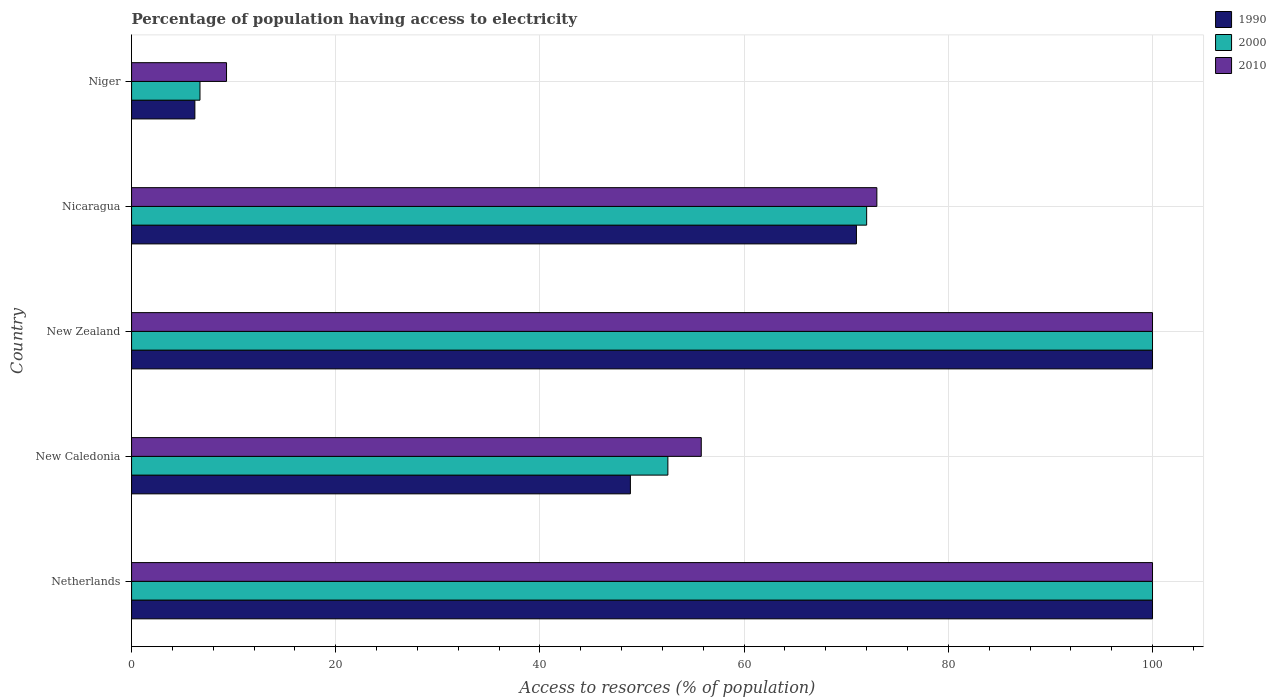How many groups of bars are there?
Offer a terse response. 5. Are the number of bars per tick equal to the number of legend labels?
Ensure brevity in your answer.  Yes. Are the number of bars on each tick of the Y-axis equal?
Your answer should be compact. Yes. How many bars are there on the 1st tick from the top?
Your answer should be very brief. 3. How many bars are there on the 4th tick from the bottom?
Provide a succinct answer. 3. What is the label of the 3rd group of bars from the top?
Provide a short and direct response. New Zealand. Across all countries, what is the minimum percentage of population having access to electricity in 2010?
Keep it short and to the point. 9.3. In which country was the percentage of population having access to electricity in 2000 minimum?
Your answer should be very brief. Niger. What is the total percentage of population having access to electricity in 2000 in the graph?
Offer a very short reply. 331.23. What is the difference between the percentage of population having access to electricity in 2010 in New Caledonia and that in New Zealand?
Make the answer very short. -44.2. What is the average percentage of population having access to electricity in 1990 per country?
Make the answer very short. 65.21. What is the difference between the percentage of population having access to electricity in 2010 and percentage of population having access to electricity in 1990 in Netherlands?
Offer a very short reply. 0. In how many countries, is the percentage of population having access to electricity in 2010 greater than 8 %?
Your answer should be compact. 5. What is the ratio of the percentage of population having access to electricity in 2000 in New Caledonia to that in Niger?
Offer a very short reply. 7.84. Is the difference between the percentage of population having access to electricity in 2010 in Netherlands and Niger greater than the difference between the percentage of population having access to electricity in 1990 in Netherlands and Niger?
Offer a terse response. No. What is the difference between the highest and the second highest percentage of population having access to electricity in 2010?
Keep it short and to the point. 0. What is the difference between the highest and the lowest percentage of population having access to electricity in 2010?
Ensure brevity in your answer.  90.7. What does the 2nd bar from the top in Netherlands represents?
Make the answer very short. 2000. What does the 2nd bar from the bottom in Niger represents?
Your response must be concise. 2000. Are all the bars in the graph horizontal?
Your answer should be compact. Yes. How many countries are there in the graph?
Your answer should be very brief. 5. Does the graph contain any zero values?
Offer a terse response. No. Does the graph contain grids?
Your answer should be compact. Yes. Where does the legend appear in the graph?
Your answer should be very brief. Top right. What is the title of the graph?
Provide a short and direct response. Percentage of population having access to electricity. What is the label or title of the X-axis?
Provide a succinct answer. Access to resorces (% of population). What is the label or title of the Y-axis?
Your response must be concise. Country. What is the Access to resorces (% of population) of 1990 in Netherlands?
Keep it short and to the point. 100. What is the Access to resorces (% of population) in 1990 in New Caledonia?
Keep it short and to the point. 48.86. What is the Access to resorces (% of population) in 2000 in New Caledonia?
Make the answer very short. 52.53. What is the Access to resorces (% of population) of 2010 in New Caledonia?
Give a very brief answer. 55.8. What is the Access to resorces (% of population) of 1990 in New Zealand?
Give a very brief answer. 100. What is the Access to resorces (% of population) of 2010 in New Zealand?
Give a very brief answer. 100. What is the Access to resorces (% of population) of 1990 in Nicaragua?
Give a very brief answer. 71. What is the Access to resorces (% of population) in 2000 in Nicaragua?
Ensure brevity in your answer.  72. Across all countries, what is the maximum Access to resorces (% of population) in 1990?
Offer a terse response. 100. Across all countries, what is the minimum Access to resorces (% of population) of 1990?
Give a very brief answer. 6.2. What is the total Access to resorces (% of population) of 1990 in the graph?
Your response must be concise. 326.06. What is the total Access to resorces (% of population) of 2000 in the graph?
Provide a short and direct response. 331.23. What is the total Access to resorces (% of population) in 2010 in the graph?
Keep it short and to the point. 338.1. What is the difference between the Access to resorces (% of population) in 1990 in Netherlands and that in New Caledonia?
Provide a short and direct response. 51.14. What is the difference between the Access to resorces (% of population) in 2000 in Netherlands and that in New Caledonia?
Your response must be concise. 47.47. What is the difference between the Access to resorces (% of population) in 2010 in Netherlands and that in New Caledonia?
Keep it short and to the point. 44.2. What is the difference between the Access to resorces (% of population) of 1990 in Netherlands and that in New Zealand?
Make the answer very short. 0. What is the difference between the Access to resorces (% of population) of 2000 in Netherlands and that in New Zealand?
Offer a terse response. 0. What is the difference between the Access to resorces (% of population) in 1990 in Netherlands and that in Nicaragua?
Your answer should be compact. 29. What is the difference between the Access to resorces (% of population) in 2000 in Netherlands and that in Nicaragua?
Your answer should be very brief. 28. What is the difference between the Access to resorces (% of population) in 2010 in Netherlands and that in Nicaragua?
Your answer should be very brief. 27. What is the difference between the Access to resorces (% of population) in 1990 in Netherlands and that in Niger?
Offer a terse response. 93.8. What is the difference between the Access to resorces (% of population) in 2000 in Netherlands and that in Niger?
Provide a succinct answer. 93.3. What is the difference between the Access to resorces (% of population) in 2010 in Netherlands and that in Niger?
Make the answer very short. 90.7. What is the difference between the Access to resorces (% of population) of 1990 in New Caledonia and that in New Zealand?
Make the answer very short. -51.14. What is the difference between the Access to resorces (% of population) of 2000 in New Caledonia and that in New Zealand?
Make the answer very short. -47.47. What is the difference between the Access to resorces (% of population) of 2010 in New Caledonia and that in New Zealand?
Keep it short and to the point. -44.2. What is the difference between the Access to resorces (% of population) of 1990 in New Caledonia and that in Nicaragua?
Offer a very short reply. -22.14. What is the difference between the Access to resorces (% of population) of 2000 in New Caledonia and that in Nicaragua?
Give a very brief answer. -19.47. What is the difference between the Access to resorces (% of population) of 2010 in New Caledonia and that in Nicaragua?
Provide a succinct answer. -17.2. What is the difference between the Access to resorces (% of population) in 1990 in New Caledonia and that in Niger?
Provide a succinct answer. 42.66. What is the difference between the Access to resorces (% of population) in 2000 in New Caledonia and that in Niger?
Your response must be concise. 45.83. What is the difference between the Access to resorces (% of population) in 2010 in New Caledonia and that in Niger?
Keep it short and to the point. 46.5. What is the difference between the Access to resorces (% of population) of 1990 in New Zealand and that in Nicaragua?
Provide a short and direct response. 29. What is the difference between the Access to resorces (% of population) of 2000 in New Zealand and that in Nicaragua?
Ensure brevity in your answer.  28. What is the difference between the Access to resorces (% of population) of 1990 in New Zealand and that in Niger?
Make the answer very short. 93.8. What is the difference between the Access to resorces (% of population) in 2000 in New Zealand and that in Niger?
Offer a terse response. 93.3. What is the difference between the Access to resorces (% of population) in 2010 in New Zealand and that in Niger?
Offer a very short reply. 90.7. What is the difference between the Access to resorces (% of population) in 1990 in Nicaragua and that in Niger?
Your answer should be compact. 64.8. What is the difference between the Access to resorces (% of population) in 2000 in Nicaragua and that in Niger?
Offer a very short reply. 65.3. What is the difference between the Access to resorces (% of population) of 2010 in Nicaragua and that in Niger?
Your answer should be compact. 63.7. What is the difference between the Access to resorces (% of population) of 1990 in Netherlands and the Access to resorces (% of population) of 2000 in New Caledonia?
Provide a short and direct response. 47.47. What is the difference between the Access to resorces (% of population) in 1990 in Netherlands and the Access to resorces (% of population) in 2010 in New Caledonia?
Your answer should be compact. 44.2. What is the difference between the Access to resorces (% of population) of 2000 in Netherlands and the Access to resorces (% of population) of 2010 in New Caledonia?
Offer a terse response. 44.2. What is the difference between the Access to resorces (% of population) in 1990 in Netherlands and the Access to resorces (% of population) in 2000 in New Zealand?
Keep it short and to the point. 0. What is the difference between the Access to resorces (% of population) of 1990 in Netherlands and the Access to resorces (% of population) of 2010 in New Zealand?
Make the answer very short. 0. What is the difference between the Access to resorces (% of population) of 2000 in Netherlands and the Access to resorces (% of population) of 2010 in New Zealand?
Ensure brevity in your answer.  0. What is the difference between the Access to resorces (% of population) in 1990 in Netherlands and the Access to resorces (% of population) in 2000 in Niger?
Offer a very short reply. 93.3. What is the difference between the Access to resorces (% of population) in 1990 in Netherlands and the Access to resorces (% of population) in 2010 in Niger?
Keep it short and to the point. 90.7. What is the difference between the Access to resorces (% of population) in 2000 in Netherlands and the Access to resorces (% of population) in 2010 in Niger?
Your answer should be compact. 90.7. What is the difference between the Access to resorces (% of population) in 1990 in New Caledonia and the Access to resorces (% of population) in 2000 in New Zealand?
Keep it short and to the point. -51.14. What is the difference between the Access to resorces (% of population) in 1990 in New Caledonia and the Access to resorces (% of population) in 2010 in New Zealand?
Keep it short and to the point. -51.14. What is the difference between the Access to resorces (% of population) of 2000 in New Caledonia and the Access to resorces (% of population) of 2010 in New Zealand?
Ensure brevity in your answer.  -47.47. What is the difference between the Access to resorces (% of population) in 1990 in New Caledonia and the Access to resorces (% of population) in 2000 in Nicaragua?
Ensure brevity in your answer.  -23.14. What is the difference between the Access to resorces (% of population) in 1990 in New Caledonia and the Access to resorces (% of population) in 2010 in Nicaragua?
Offer a very short reply. -24.14. What is the difference between the Access to resorces (% of population) of 2000 in New Caledonia and the Access to resorces (% of population) of 2010 in Nicaragua?
Ensure brevity in your answer.  -20.47. What is the difference between the Access to resorces (% of population) of 1990 in New Caledonia and the Access to resorces (% of population) of 2000 in Niger?
Your answer should be compact. 42.16. What is the difference between the Access to resorces (% of population) of 1990 in New Caledonia and the Access to resorces (% of population) of 2010 in Niger?
Make the answer very short. 39.56. What is the difference between the Access to resorces (% of population) of 2000 in New Caledonia and the Access to resorces (% of population) of 2010 in Niger?
Offer a terse response. 43.23. What is the difference between the Access to resorces (% of population) in 1990 in New Zealand and the Access to resorces (% of population) in 2000 in Niger?
Provide a short and direct response. 93.3. What is the difference between the Access to resorces (% of population) of 1990 in New Zealand and the Access to resorces (% of population) of 2010 in Niger?
Make the answer very short. 90.7. What is the difference between the Access to resorces (% of population) of 2000 in New Zealand and the Access to resorces (% of population) of 2010 in Niger?
Ensure brevity in your answer.  90.7. What is the difference between the Access to resorces (% of population) of 1990 in Nicaragua and the Access to resorces (% of population) of 2000 in Niger?
Offer a very short reply. 64.3. What is the difference between the Access to resorces (% of population) of 1990 in Nicaragua and the Access to resorces (% of population) of 2010 in Niger?
Provide a short and direct response. 61.7. What is the difference between the Access to resorces (% of population) of 2000 in Nicaragua and the Access to resorces (% of population) of 2010 in Niger?
Give a very brief answer. 62.7. What is the average Access to resorces (% of population) of 1990 per country?
Offer a very short reply. 65.21. What is the average Access to resorces (% of population) in 2000 per country?
Your response must be concise. 66.25. What is the average Access to resorces (% of population) in 2010 per country?
Your response must be concise. 67.62. What is the difference between the Access to resorces (% of population) in 1990 and Access to resorces (% of population) in 2000 in Netherlands?
Provide a succinct answer. 0. What is the difference between the Access to resorces (% of population) in 1990 and Access to resorces (% of population) in 2000 in New Caledonia?
Provide a succinct answer. -3.67. What is the difference between the Access to resorces (% of population) of 1990 and Access to resorces (% of population) of 2010 in New Caledonia?
Keep it short and to the point. -6.94. What is the difference between the Access to resorces (% of population) of 2000 and Access to resorces (% of population) of 2010 in New Caledonia?
Your answer should be compact. -3.27. What is the difference between the Access to resorces (% of population) of 2000 and Access to resorces (% of population) of 2010 in Nicaragua?
Keep it short and to the point. -1. What is the ratio of the Access to resorces (% of population) of 1990 in Netherlands to that in New Caledonia?
Offer a very short reply. 2.05. What is the ratio of the Access to resorces (% of population) of 2000 in Netherlands to that in New Caledonia?
Your answer should be compact. 1.9. What is the ratio of the Access to resorces (% of population) in 2010 in Netherlands to that in New Caledonia?
Provide a succinct answer. 1.79. What is the ratio of the Access to resorces (% of population) in 1990 in Netherlands to that in New Zealand?
Provide a succinct answer. 1. What is the ratio of the Access to resorces (% of population) of 2000 in Netherlands to that in New Zealand?
Offer a very short reply. 1. What is the ratio of the Access to resorces (% of population) in 2010 in Netherlands to that in New Zealand?
Offer a terse response. 1. What is the ratio of the Access to resorces (% of population) in 1990 in Netherlands to that in Nicaragua?
Offer a very short reply. 1.41. What is the ratio of the Access to resorces (% of population) of 2000 in Netherlands to that in Nicaragua?
Ensure brevity in your answer.  1.39. What is the ratio of the Access to resorces (% of population) of 2010 in Netherlands to that in Nicaragua?
Provide a short and direct response. 1.37. What is the ratio of the Access to resorces (% of population) in 1990 in Netherlands to that in Niger?
Offer a very short reply. 16.13. What is the ratio of the Access to resorces (% of population) in 2000 in Netherlands to that in Niger?
Keep it short and to the point. 14.93. What is the ratio of the Access to resorces (% of population) in 2010 in Netherlands to that in Niger?
Provide a succinct answer. 10.75. What is the ratio of the Access to resorces (% of population) in 1990 in New Caledonia to that in New Zealand?
Keep it short and to the point. 0.49. What is the ratio of the Access to resorces (% of population) of 2000 in New Caledonia to that in New Zealand?
Offer a terse response. 0.53. What is the ratio of the Access to resorces (% of population) of 2010 in New Caledonia to that in New Zealand?
Give a very brief answer. 0.56. What is the ratio of the Access to resorces (% of population) of 1990 in New Caledonia to that in Nicaragua?
Make the answer very short. 0.69. What is the ratio of the Access to resorces (% of population) of 2000 in New Caledonia to that in Nicaragua?
Your answer should be compact. 0.73. What is the ratio of the Access to resorces (% of population) in 2010 in New Caledonia to that in Nicaragua?
Your response must be concise. 0.76. What is the ratio of the Access to resorces (% of population) in 1990 in New Caledonia to that in Niger?
Offer a terse response. 7.88. What is the ratio of the Access to resorces (% of population) in 2000 in New Caledonia to that in Niger?
Provide a succinct answer. 7.84. What is the ratio of the Access to resorces (% of population) in 2010 in New Caledonia to that in Niger?
Provide a succinct answer. 6. What is the ratio of the Access to resorces (% of population) in 1990 in New Zealand to that in Nicaragua?
Give a very brief answer. 1.41. What is the ratio of the Access to resorces (% of population) of 2000 in New Zealand to that in Nicaragua?
Offer a terse response. 1.39. What is the ratio of the Access to resorces (% of population) of 2010 in New Zealand to that in Nicaragua?
Ensure brevity in your answer.  1.37. What is the ratio of the Access to resorces (% of population) of 1990 in New Zealand to that in Niger?
Your response must be concise. 16.13. What is the ratio of the Access to resorces (% of population) in 2000 in New Zealand to that in Niger?
Your response must be concise. 14.93. What is the ratio of the Access to resorces (% of population) in 2010 in New Zealand to that in Niger?
Your response must be concise. 10.75. What is the ratio of the Access to resorces (% of population) in 1990 in Nicaragua to that in Niger?
Your response must be concise. 11.45. What is the ratio of the Access to resorces (% of population) in 2000 in Nicaragua to that in Niger?
Your response must be concise. 10.75. What is the ratio of the Access to resorces (% of population) in 2010 in Nicaragua to that in Niger?
Keep it short and to the point. 7.85. What is the difference between the highest and the second highest Access to resorces (% of population) of 1990?
Make the answer very short. 0. What is the difference between the highest and the second highest Access to resorces (% of population) in 2010?
Offer a very short reply. 0. What is the difference between the highest and the lowest Access to resorces (% of population) of 1990?
Your answer should be compact. 93.8. What is the difference between the highest and the lowest Access to resorces (% of population) of 2000?
Provide a short and direct response. 93.3. What is the difference between the highest and the lowest Access to resorces (% of population) in 2010?
Your answer should be compact. 90.7. 